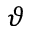<formula> <loc_0><loc_0><loc_500><loc_500>\vartheta</formula> 